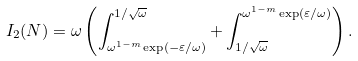<formula> <loc_0><loc_0><loc_500><loc_500>I _ { 2 } ( N ) = \omega \left ( \int _ { \omega ^ { 1 - m } \exp \left ( - \varepsilon / \omega \right ) } ^ { 1 / \sqrt { \omega } } + \int _ { 1 / \sqrt { \omega } } ^ { \omega ^ { 1 - m } \exp \left ( \varepsilon / \omega \right ) } \right ) .</formula> 